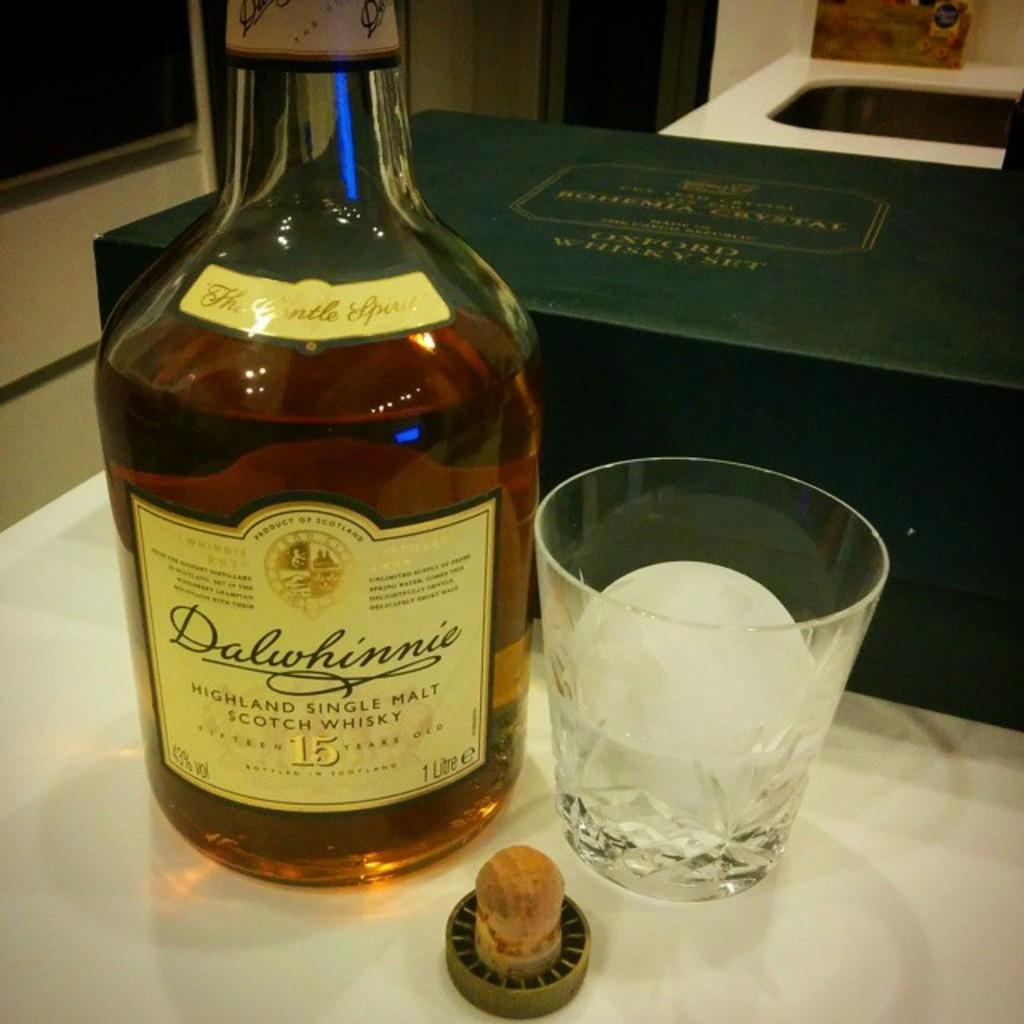What type of container is present in the image? There is a bottle and a glass in the image. Where are the bottle and glass located? Both the bottle and glass are on a table. What else can be seen at the back side of the image? There is a green box at the back side of the image. What riddle does the queen ask about the banana in the image? There is no queen or banana present in the image, so no riddle can be asked. 